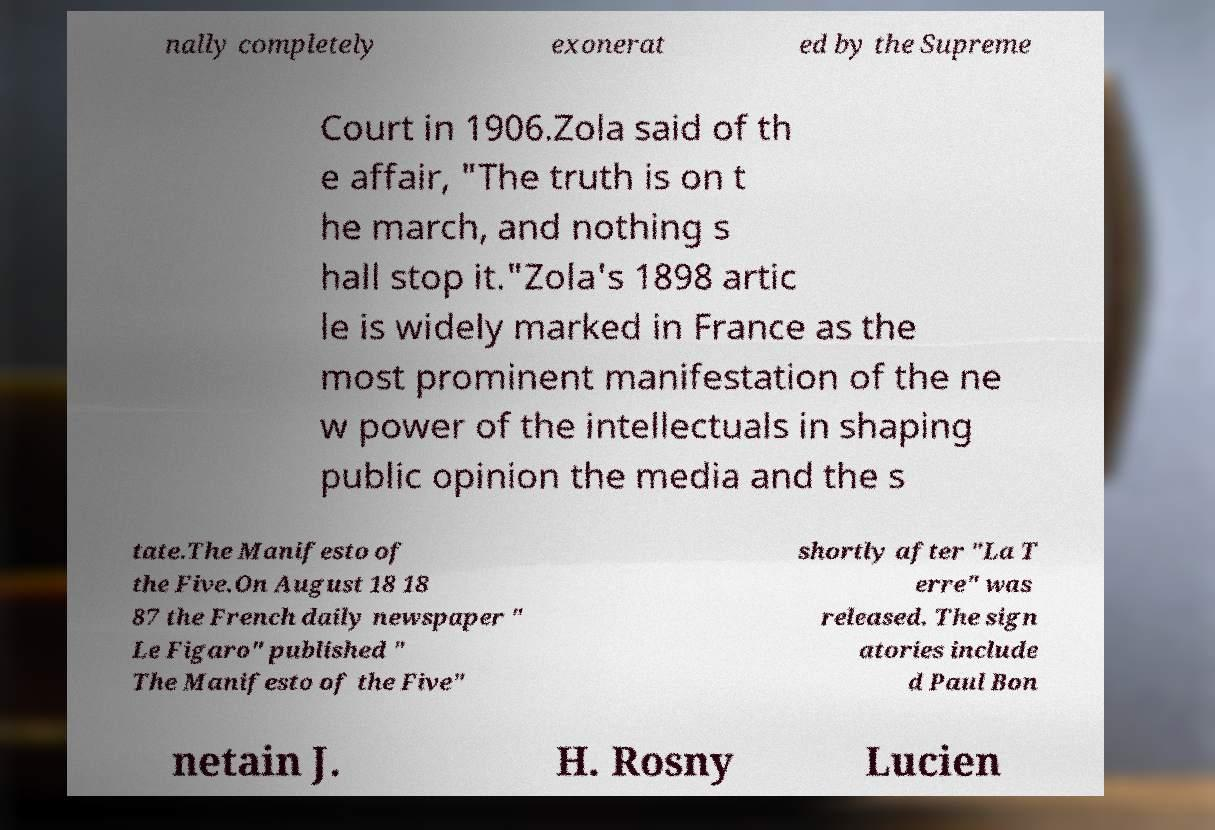Please identify and transcribe the text found in this image. nally completely exonerat ed by the Supreme Court in 1906.Zola said of th e affair, "The truth is on t he march, and nothing s hall stop it."Zola's 1898 artic le is widely marked in France as the most prominent manifestation of the ne w power of the intellectuals in shaping public opinion the media and the s tate.The Manifesto of the Five.On August 18 18 87 the French daily newspaper " Le Figaro" published " The Manifesto of the Five" shortly after "La T erre" was released. The sign atories include d Paul Bon netain J. H. Rosny Lucien 